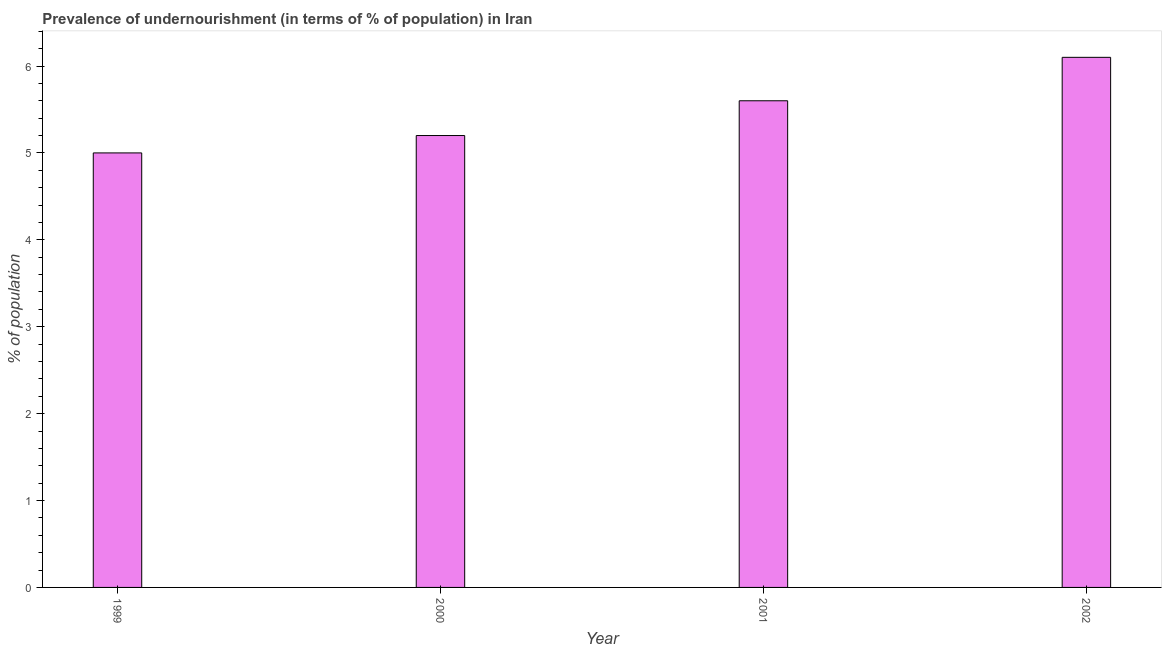Does the graph contain grids?
Offer a very short reply. No. What is the title of the graph?
Your answer should be compact. Prevalence of undernourishment (in terms of % of population) in Iran. What is the label or title of the X-axis?
Keep it short and to the point. Year. What is the label or title of the Y-axis?
Give a very brief answer. % of population. Across all years, what is the maximum percentage of undernourished population?
Offer a very short reply. 6.1. In which year was the percentage of undernourished population maximum?
Ensure brevity in your answer.  2002. In which year was the percentage of undernourished population minimum?
Ensure brevity in your answer.  1999. What is the sum of the percentage of undernourished population?
Your response must be concise. 21.9. What is the average percentage of undernourished population per year?
Your answer should be very brief. 5.47. What is the median percentage of undernourished population?
Give a very brief answer. 5.4. Do a majority of the years between 1999 and 2002 (inclusive) have percentage of undernourished population greater than 4.2 %?
Your response must be concise. Yes. What is the ratio of the percentage of undernourished population in 1999 to that in 2002?
Your response must be concise. 0.82. Is the difference between the percentage of undernourished population in 1999 and 2000 greater than the difference between any two years?
Offer a terse response. No. What is the difference between the highest and the second highest percentage of undernourished population?
Your answer should be very brief. 0.5. Is the sum of the percentage of undernourished population in 1999 and 2000 greater than the maximum percentage of undernourished population across all years?
Keep it short and to the point. Yes. In how many years, is the percentage of undernourished population greater than the average percentage of undernourished population taken over all years?
Your response must be concise. 2. How many bars are there?
Offer a very short reply. 4. Are all the bars in the graph horizontal?
Offer a terse response. No. What is the difference between two consecutive major ticks on the Y-axis?
Offer a terse response. 1. What is the % of population in 1999?
Keep it short and to the point. 5. What is the % of population in 2000?
Offer a terse response. 5.2. What is the % of population of 2002?
Ensure brevity in your answer.  6.1. What is the difference between the % of population in 1999 and 2000?
Give a very brief answer. -0.2. What is the difference between the % of population in 2000 and 2001?
Your response must be concise. -0.4. What is the difference between the % of population in 2000 and 2002?
Your response must be concise. -0.9. What is the difference between the % of population in 2001 and 2002?
Offer a very short reply. -0.5. What is the ratio of the % of population in 1999 to that in 2000?
Provide a succinct answer. 0.96. What is the ratio of the % of population in 1999 to that in 2001?
Your answer should be compact. 0.89. What is the ratio of the % of population in 1999 to that in 2002?
Your answer should be compact. 0.82. What is the ratio of the % of population in 2000 to that in 2001?
Ensure brevity in your answer.  0.93. What is the ratio of the % of population in 2000 to that in 2002?
Offer a terse response. 0.85. What is the ratio of the % of population in 2001 to that in 2002?
Provide a short and direct response. 0.92. 